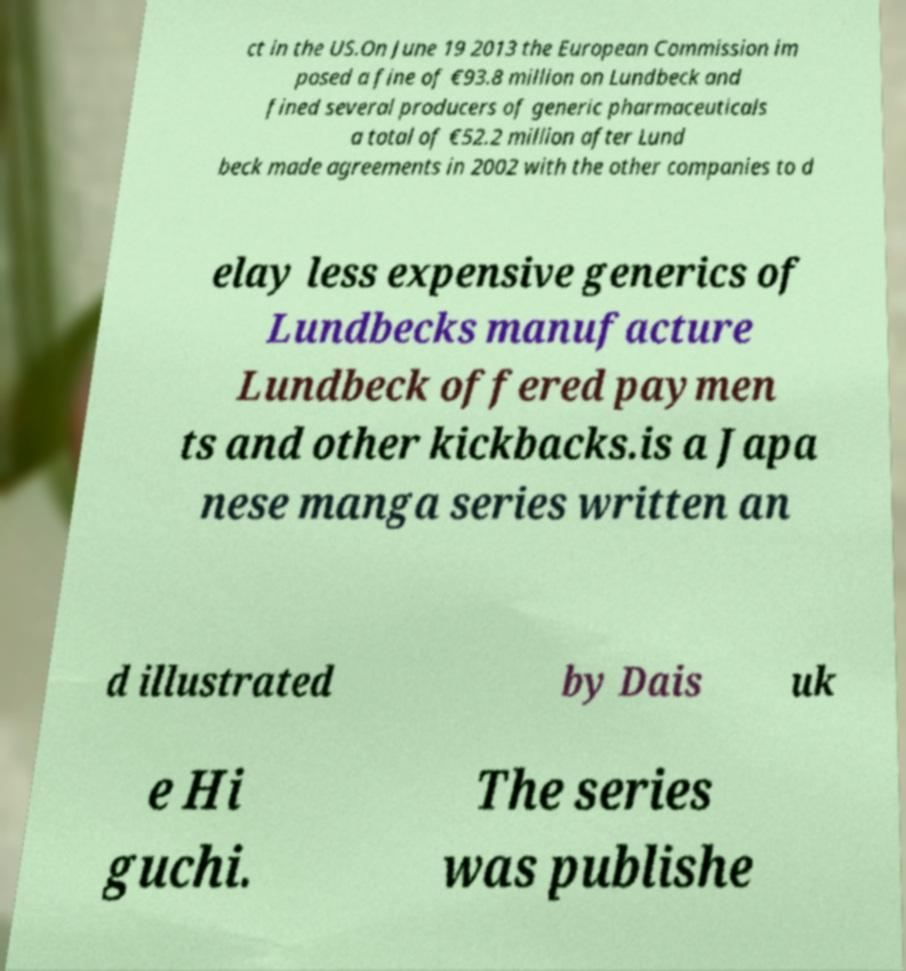I need the written content from this picture converted into text. Can you do that? ct in the US.On June 19 2013 the European Commission im posed a fine of €93.8 million on Lundbeck and fined several producers of generic pharmaceuticals a total of €52.2 million after Lund beck made agreements in 2002 with the other companies to d elay less expensive generics of Lundbecks manufacture Lundbeck offered paymen ts and other kickbacks.is a Japa nese manga series written an d illustrated by Dais uk e Hi guchi. The series was publishe 